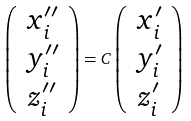<formula> <loc_0><loc_0><loc_500><loc_500>\left ( \begin{array} { c } x _ { i } ^ { \prime \prime } \\ y _ { i } ^ { \prime \prime } \\ z _ { i } ^ { \prime \prime } \end{array} \right ) = C \left ( \begin{array} { c } x _ { i } ^ { \prime } \\ y _ { i } ^ { \prime } \\ z _ { i } ^ { \prime } \end{array} \right )</formula> 